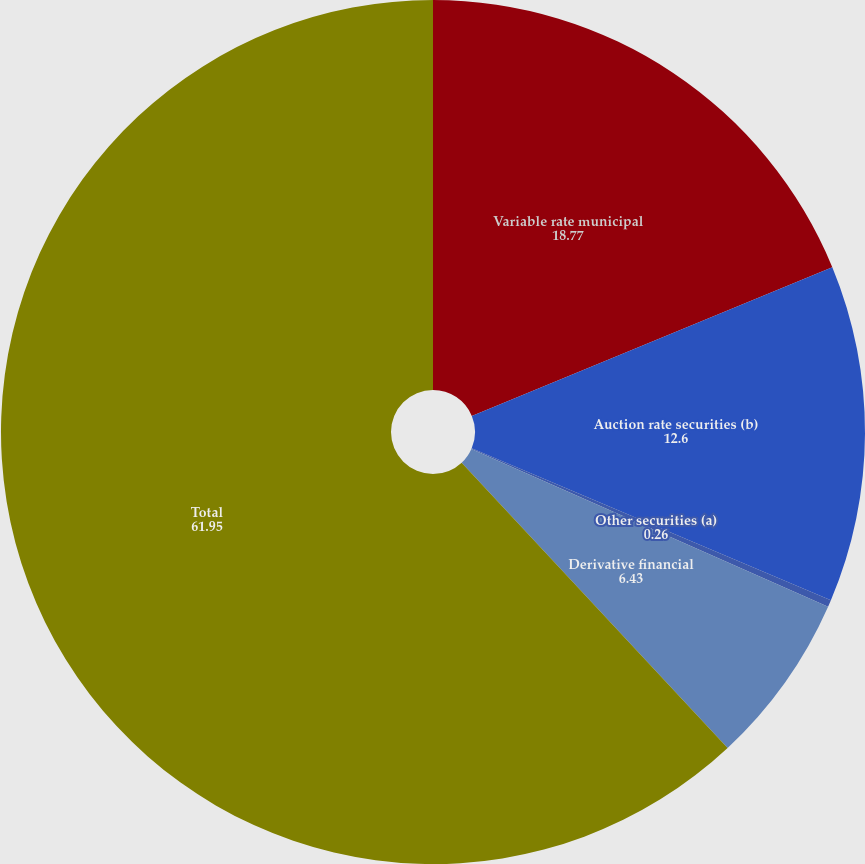Convert chart to OTSL. <chart><loc_0><loc_0><loc_500><loc_500><pie_chart><fcel>Variable rate municipal<fcel>Auction rate securities (b)<fcel>Other securities (a)<fcel>Derivative financial<fcel>Total<nl><fcel>18.77%<fcel>12.6%<fcel>0.26%<fcel>6.43%<fcel>61.95%<nl></chart> 